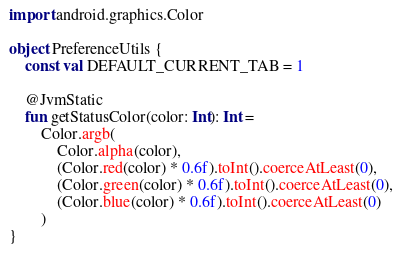<code> <loc_0><loc_0><loc_500><loc_500><_Kotlin_>
import android.graphics.Color

object PreferenceUtils {
    const val DEFAULT_CURRENT_TAB = 1

    @JvmStatic
    fun getStatusColor(color: Int): Int =
        Color.argb(
            Color.alpha(color),
            (Color.red(color) * 0.6f).toInt().coerceAtLeast(0),
            (Color.green(color) * 0.6f).toInt().coerceAtLeast(0),
            (Color.blue(color) * 0.6f).toInt().coerceAtLeast(0)
        )
}
</code> 